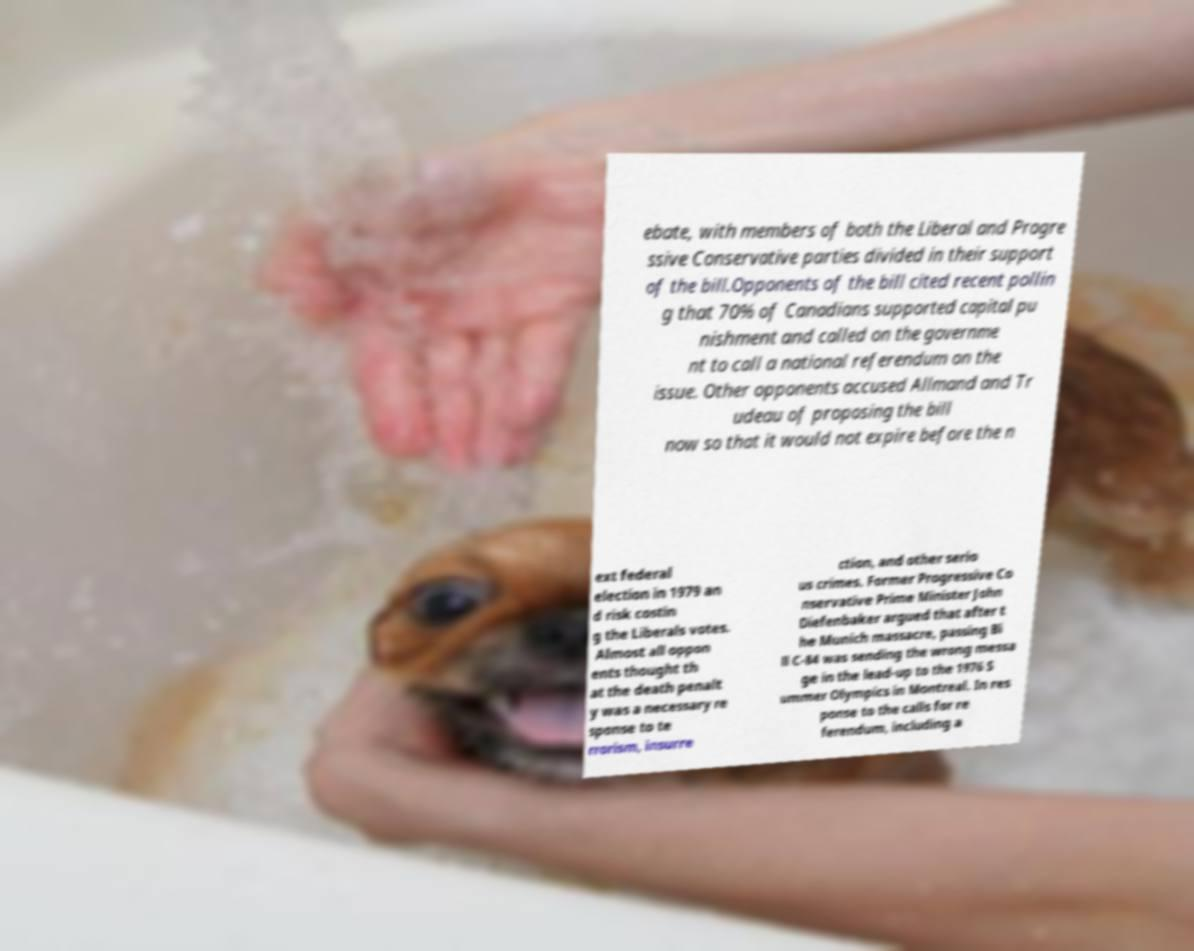For documentation purposes, I need the text within this image transcribed. Could you provide that? ebate, with members of both the Liberal and Progre ssive Conservative parties divided in their support of the bill.Opponents of the bill cited recent pollin g that 70% of Canadians supported capital pu nishment and called on the governme nt to call a national referendum on the issue. Other opponents accused Allmand and Tr udeau of proposing the bill now so that it would not expire before the n ext federal election in 1979 an d risk costin g the Liberals votes. Almost all oppon ents thought th at the death penalt y was a necessary re sponse to te rrorism, insurre ction, and other serio us crimes. Former Progressive Co nservative Prime Minister John Diefenbaker argued that after t he Munich massacre, passing Bi ll C-84 was sending the wrong messa ge in the lead-up to the 1976 S ummer Olympics in Montreal. In res ponse to the calls for re ferendum, including a 